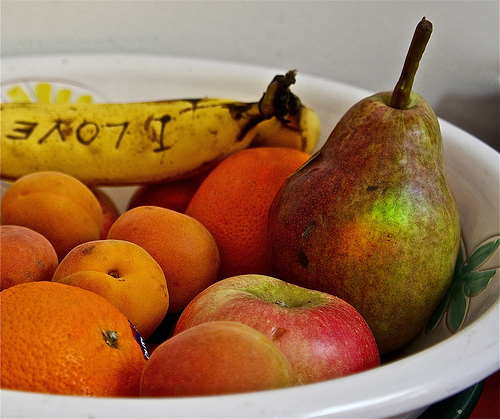<image>
Can you confirm if the banana is on the orange? No. The banana is not positioned on the orange. They may be near each other, but the banana is not supported by or resting on top of the orange. 